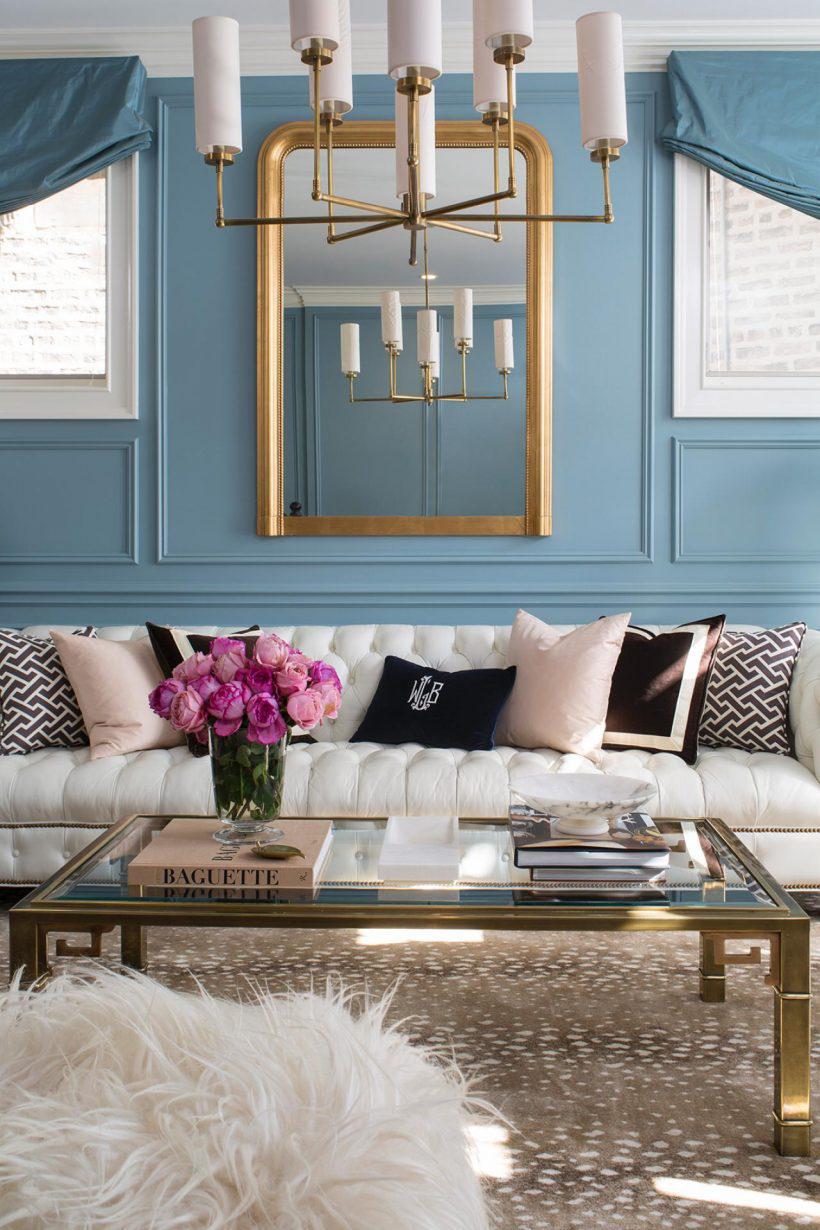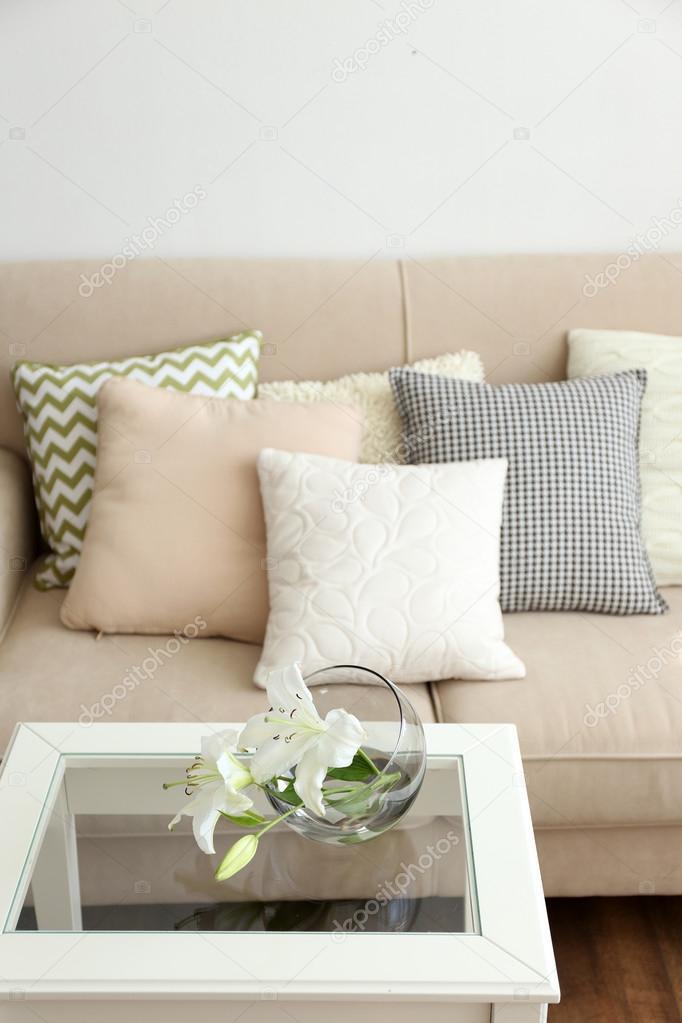The first image is the image on the left, the second image is the image on the right. Given the left and right images, does the statement "There is a single table lamp with a white shade to the right of a couch in the left image." hold true? Answer yes or no. No. The first image is the image on the left, the second image is the image on the right. Examine the images to the left and right. Is the description "The room on the left features a large printed rug, a vase filled with hot pink flowers, and an upholstered, tufted piece of furniture." accurate? Answer yes or no. Yes. 